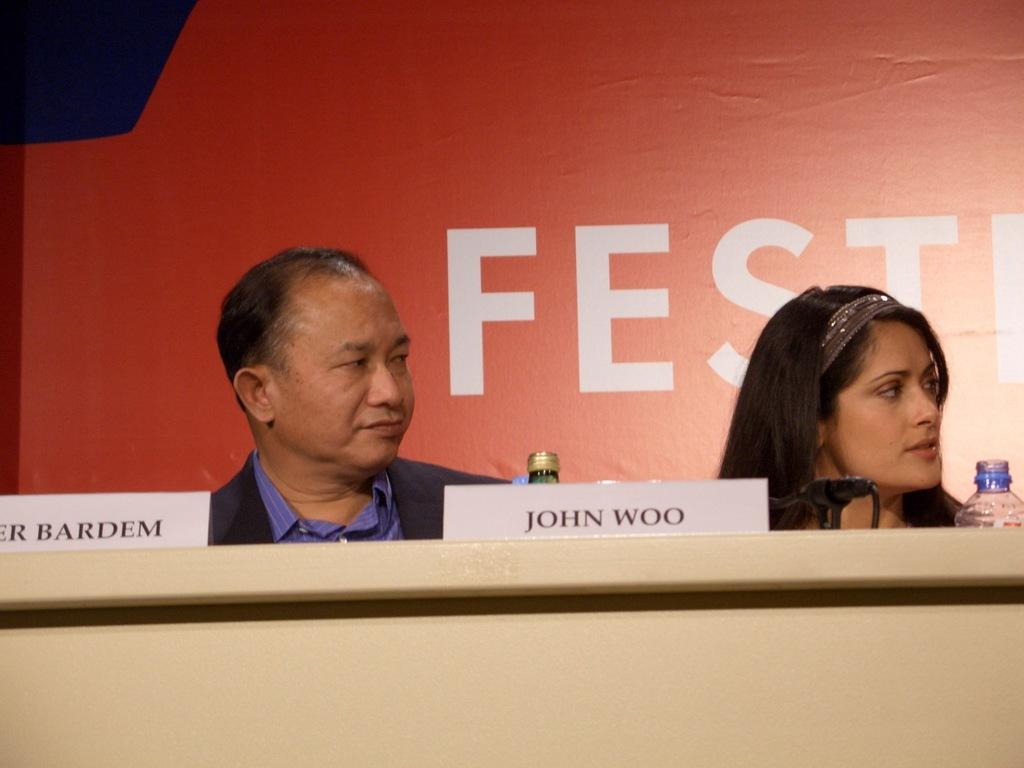How many people are in the image? There is a man and a woman in the image. What objects are on the table in the image? Name boards, bottles, and a microphone are on the table in the image. What can be seen on the wall in the background? There is writing on the wall in the background. What invention is the stranger demonstrating in the image? There is no stranger present in the image, nor is there any invention being demonstrated. 